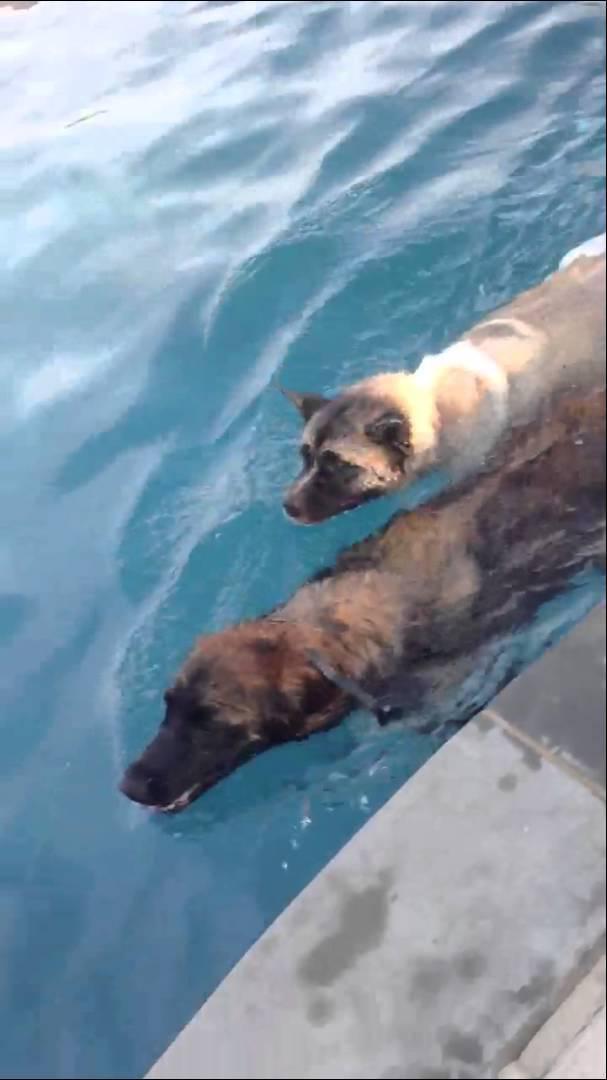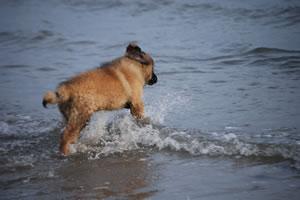The first image is the image on the left, the second image is the image on the right. Given the left and right images, does the statement "An image shows one forward-facing dog swimming in a natural body of water." hold true? Answer yes or no. No. 